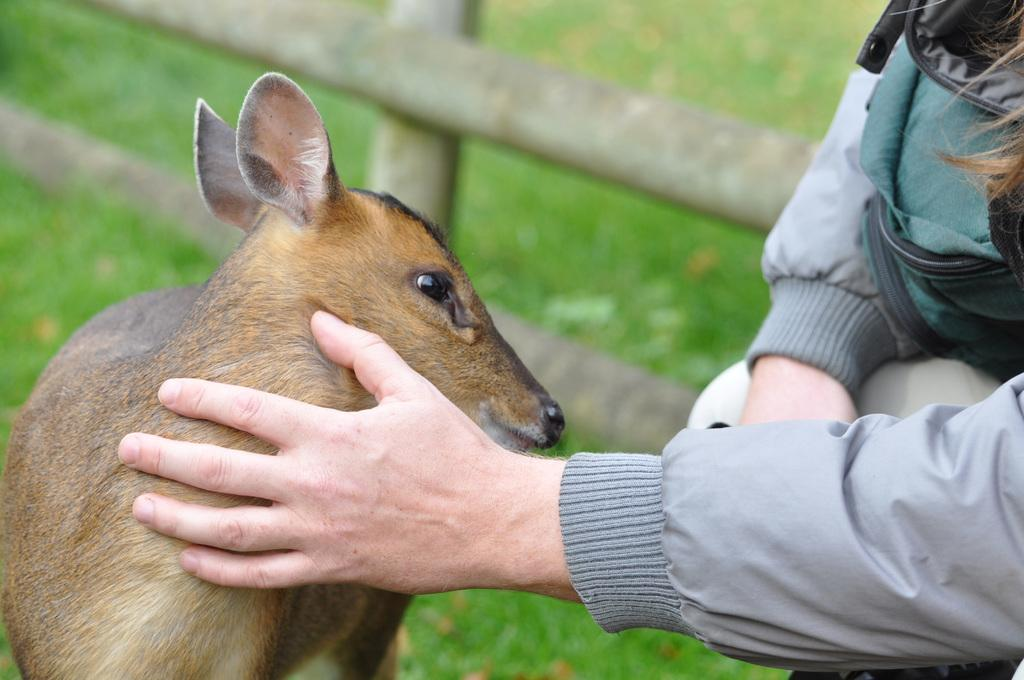What type of animal is in the image? The type of animal cannot be determined from the provided facts. What is the person in the image doing? The actions of the person in the image cannot be determined from the provided facts. What is the fence used for in the image? The purpose of the fence in the image cannot be determined from the provided facts. What can be seen in the background of the image? There is grass visible in the background of the image. What type of suit is the person wearing in the image? There is no mention of a suit in the provided facts, and therefore no such information can be determined. 